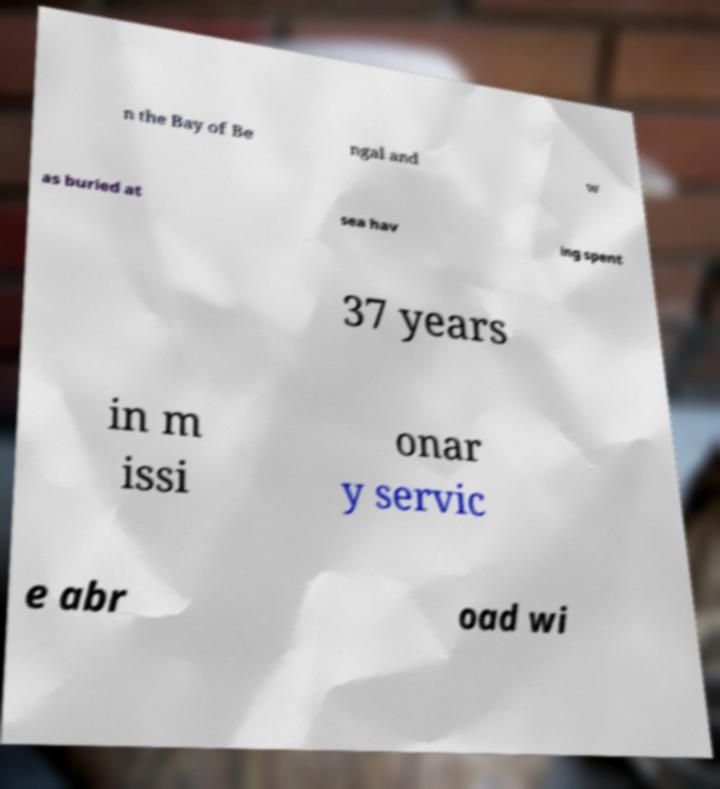I need the written content from this picture converted into text. Can you do that? n the Bay of Be ngal and w as buried at sea hav ing spent 37 years in m issi onar y servic e abr oad wi 